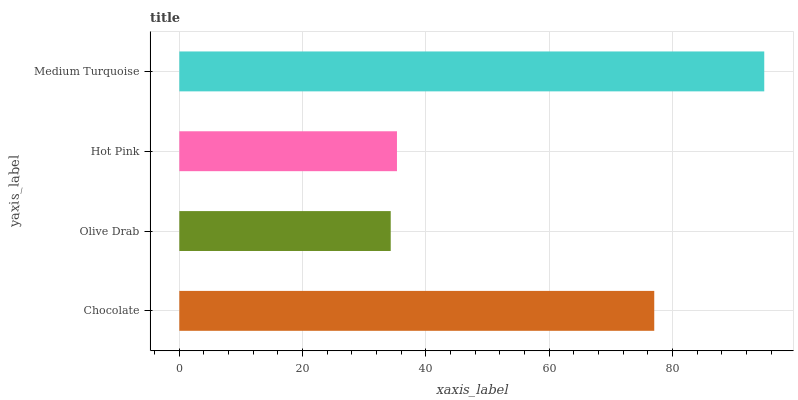Is Olive Drab the minimum?
Answer yes or no. Yes. Is Medium Turquoise the maximum?
Answer yes or no. Yes. Is Hot Pink the minimum?
Answer yes or no. No. Is Hot Pink the maximum?
Answer yes or no. No. Is Hot Pink greater than Olive Drab?
Answer yes or no. Yes. Is Olive Drab less than Hot Pink?
Answer yes or no. Yes. Is Olive Drab greater than Hot Pink?
Answer yes or no. No. Is Hot Pink less than Olive Drab?
Answer yes or no. No. Is Chocolate the high median?
Answer yes or no. Yes. Is Hot Pink the low median?
Answer yes or no. Yes. Is Olive Drab the high median?
Answer yes or no. No. Is Olive Drab the low median?
Answer yes or no. No. 